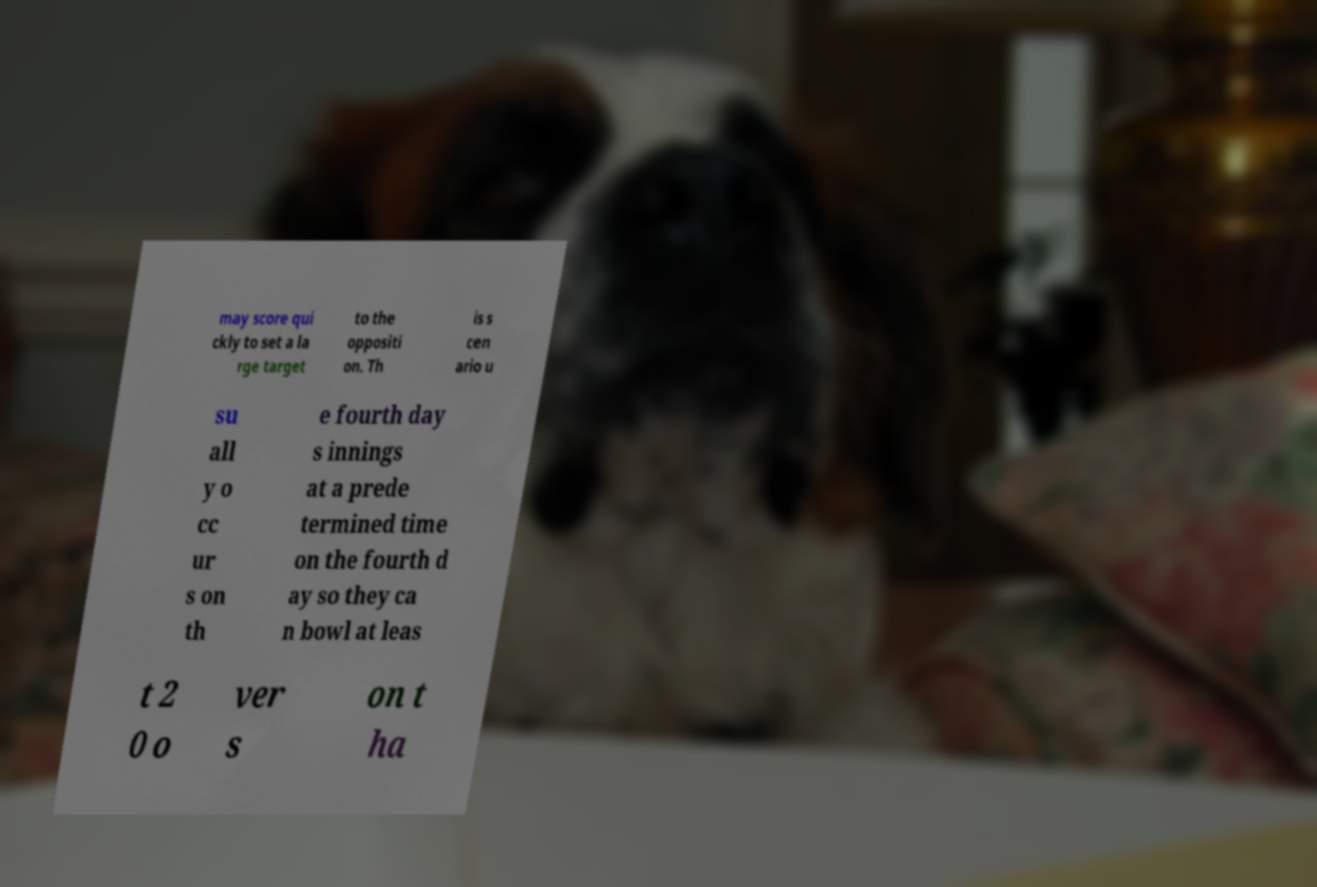Can you read and provide the text displayed in the image?This photo seems to have some interesting text. Can you extract and type it out for me? may score qui ckly to set a la rge target to the oppositi on. Th is s cen ario u su all y o cc ur s on th e fourth day s innings at a prede termined time on the fourth d ay so they ca n bowl at leas t 2 0 o ver s on t ha 